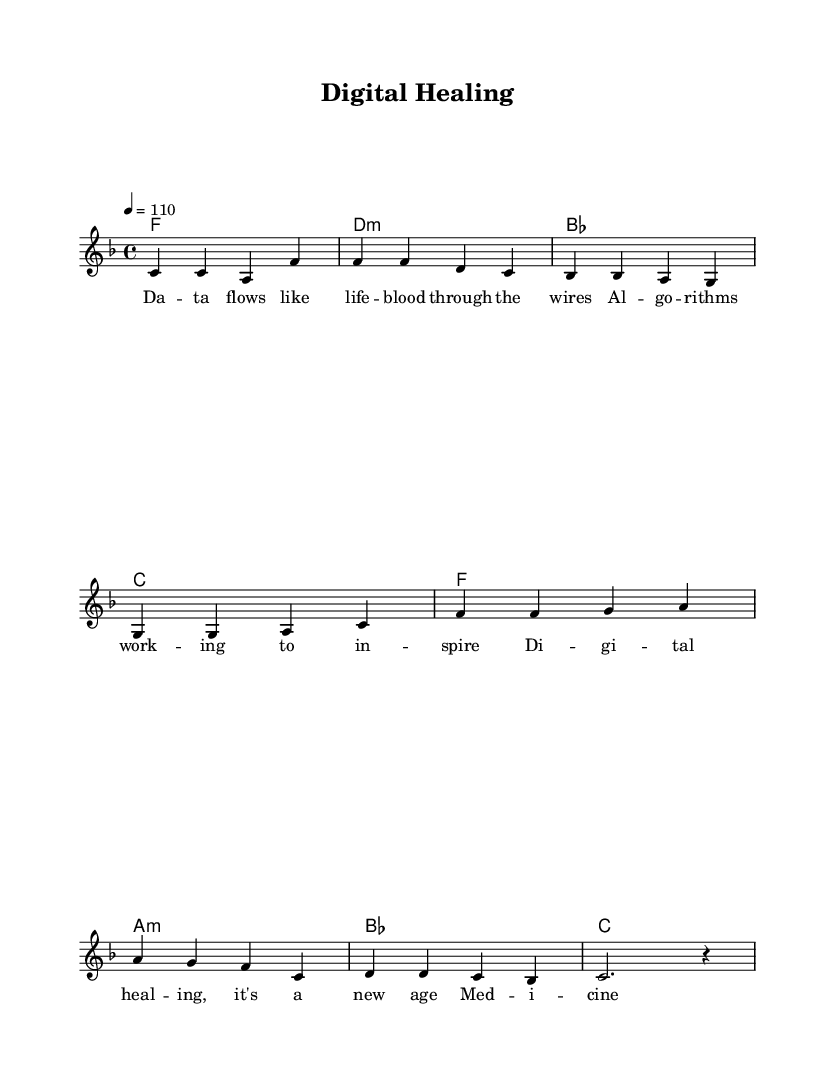What is the key signature of this music? The key signature is indicated at the beginning of the staff, showing one flat which corresponds to the key of F major.
Answer: F major What is the time signature of this piece? The time signature is also shown at the beginning, indicating that there are four beats per measure, which is written as 4/4.
Answer: 4/4 What is the tempo marking for this piece? The tempo marking is located at the top of the sheet music and indicates a speed of 110 beats per minute, denoted as "4 = 110".
Answer: 110 How many measures are in the discussed sections of the music? The verse consists of four measures and the chorus also consists of four measures, making a total of eight measures.
Answer: 8 measures What is the first lyric sung in the verse? The first lyric can be found below the melody line and reads "Da -- ta", which is the start of the verse.
Answer: Da -- ta What chord follows the "f" chord in the chorus? In the chorus chord progression after the "f" chord, the next chord shown is "a:min". Therefore, it confirms the sequence.
Answer: a:min What genre does this piece best represent? Given the mentioned characteristics and lyrical themes in the sheet music, it can be classified under the genre of Rhythm and Blues.
Answer: Rhythm and Blues 